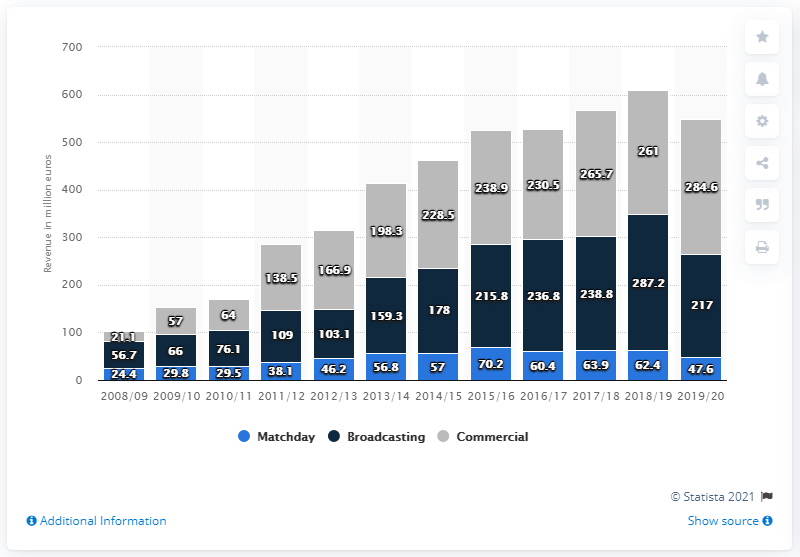Indicate a few pertinent items in this graphic. In the 2019/2020 fiscal year, Manchester City generated 284.6 million US dollars from sponsorship, merchandising, stadium tours, and other commercial operations. 